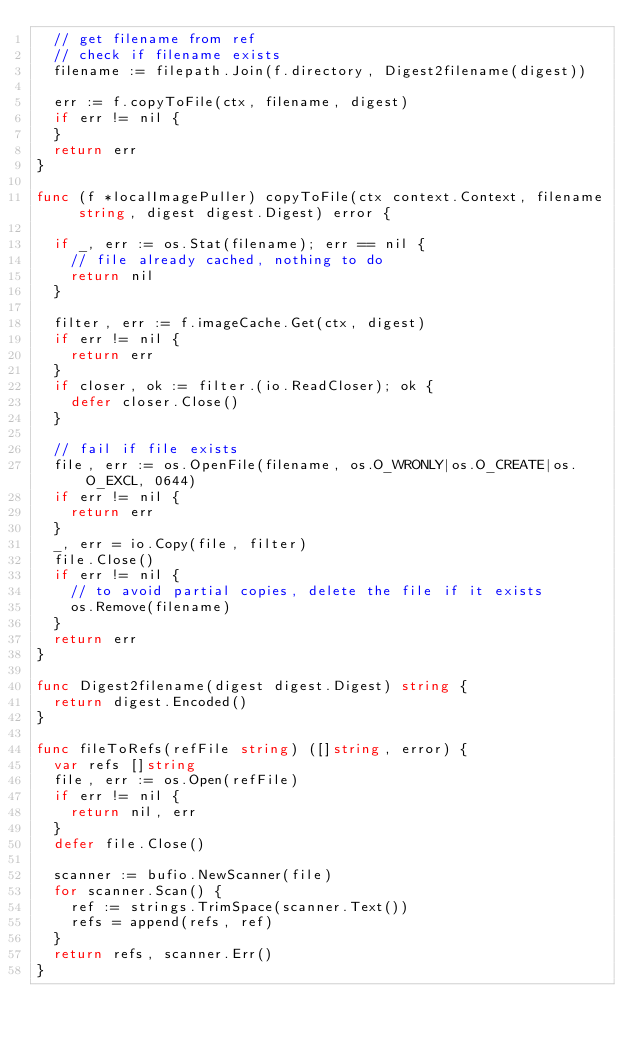<code> <loc_0><loc_0><loc_500><loc_500><_Go_>	// get filename from ref
	// check if filename exists
	filename := filepath.Join(f.directory, Digest2filename(digest))

	err := f.copyToFile(ctx, filename, digest)
	if err != nil {
	}
	return err
}

func (f *localImagePuller) copyToFile(ctx context.Context, filename string, digest digest.Digest) error {

	if _, err := os.Stat(filename); err == nil {
		// file already cached, nothing to do
		return nil
	}

	filter, err := f.imageCache.Get(ctx, digest)
	if err != nil {
		return err
	}
	if closer, ok := filter.(io.ReadCloser); ok {
		defer closer.Close()
	}

	// fail if file exists
	file, err := os.OpenFile(filename, os.O_WRONLY|os.O_CREATE|os.O_EXCL, 0644)
	if err != nil {
		return err
	}
	_, err = io.Copy(file, filter)
	file.Close()
	if err != nil {
		// to avoid partial copies, delete the file if it exists
		os.Remove(filename)
	}
	return err
}

func Digest2filename(digest digest.Digest) string {
	return digest.Encoded()
}

func fileToRefs(refFile string) ([]string, error) {
	var refs []string
	file, err := os.Open(refFile)
	if err != nil {
		return nil, err
	}
	defer file.Close()

	scanner := bufio.NewScanner(file)
	for scanner.Scan() {
		ref := strings.TrimSpace(scanner.Text())
		refs = append(refs, ref)
	}
	return refs, scanner.Err()
}
</code> 